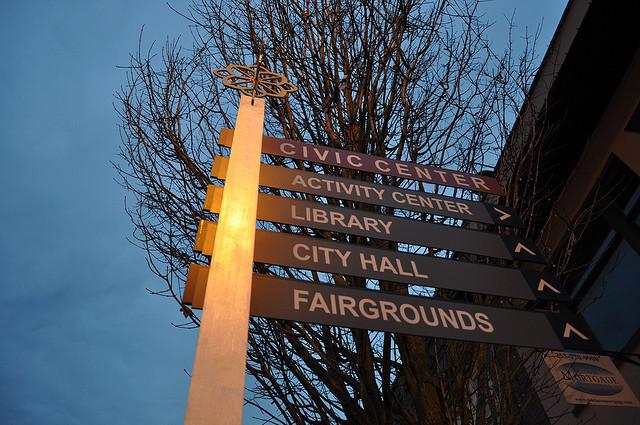What number of signs are hanging from this pole?
Keep it brief. 5. What do the arrow symbols mean?
Give a very brief answer. Direction. What color is the sky?
Keep it brief. Blue. 